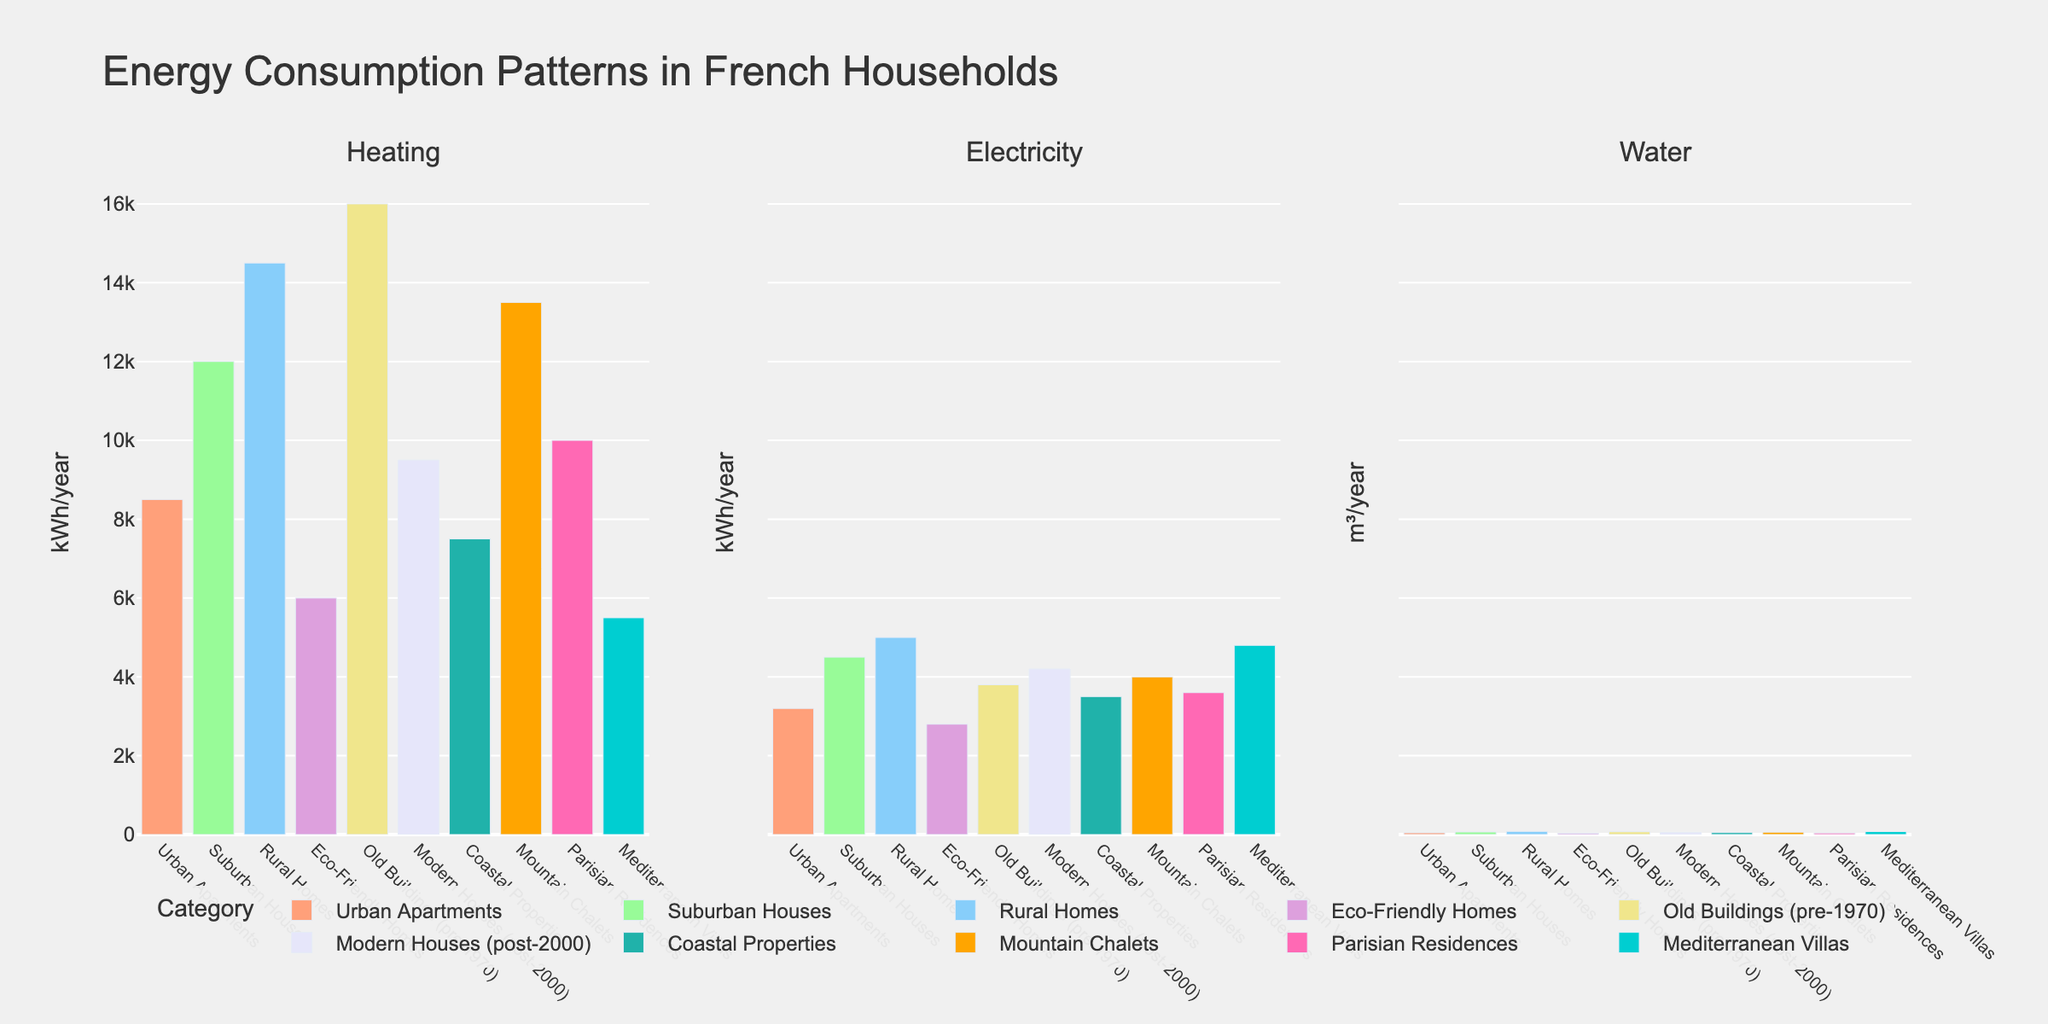Which type of household has the highest heating consumption? Observe the heights of the bars in the "Heating" subplot. Old Buildings (pre-1970) has the tallest bar.
Answer: Old Buildings (pre-1970) Which household type uses the least electricity annually? Check the shortest bar in the "Electricity" subplot. Eco-Friendly Homes has the shortest bar.
Answer: Eco-Friendly Homes What is the total water consumption of Suburban Houses and Mediterranean Villas? Add the heights of the bars for Suburban Houses (65 m³/year) and Mediterranean Villas (75 m³/year) in the "Water" subplot. 65 + 75 = 140
Answer: 140 m³/year How does the electricity consumption of Coastal Properties compare with Urban Apartments? Compare the heights of the bars for Coastal Properties and Urban Apartments in the "Electricity" subplot. Coastal Properties (3500 kWh/year) and Urban Apartments (3200 kWh/year). Coastal Properties uses more.
Answer: Coastal Properties uses more Which type of household has nearly double the electricity consumption of Eco-Friendly Homes? Eco-Friendly Homes has 2800 kWh/year in the "Electricity" subplot. Identify which type has about 5600 kWh/year. No category matches exactly, but Mediterranean Villas use 4800 kWh/year.
Answer: Mediterranean Villas (4800 kWh/year) Which household type has the least water consumption, and by how much less is it compared to Rural Homes? The shortest bar in the "Water" subplot is for Eco-Friendly Homes (35 m³/year). Rural Homes use 80 m³/year. 80 - 35 = 45
Answer: Eco-Friendly Homes, 45 m³/year less What is the average heating consumption for Eco-Friendly Homes, Urban Apartments, and Suburban Houses? Sum their heating consumptions: Eco-Friendly Homes (6000) + Urban Apartments (8500) + Suburban Houses (12000) = 26500 kWh/year. Average is 26500 / 3 = 8833.33
Answer: 8833.33 kWh/year Which household category has the most consistent energy usage across heating, electricity, and water? Compare the bars for each category across all three plots. Modern Houses (post-2000) appear quite balanced (9500, 4200, 55).
Answer: Modern Houses (post-2000) 